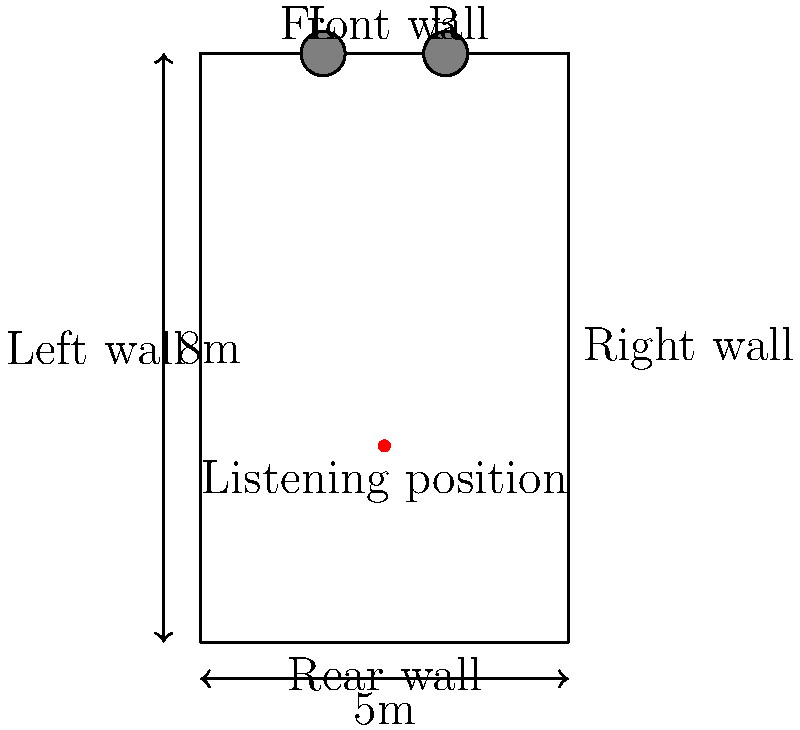In a rectangular room measuring 5m x 8m, where should the speakers be placed for optimal stereo imaging, and what is the ideal distance between them? Assume the listening position is 1/3 of the room length from the rear wall. To determine the optimal speaker placement for stereo imaging in this rectangular room, we'll follow these steps:

1. Identify the listening position:
   - The listening position is 1/3 of the room length from the rear wall.
   - In this case, it's at $8m \times \frac{1}{3} = 2.67m$ from the rear wall.

2. Determine speaker placement:
   - For optimal stereo imaging, speakers should form an equilateral triangle with the listening position.
   - Place speakers along the front wall (8m side).

3. Calculate speaker distance:
   - The distance between speakers should be equal to the distance from each speaker to the listening position.
   - This creates an equilateral triangle.

4. Use the 60-degree rule:
   - In an equilateral triangle, each angle is 60 degrees.
   - The speakers should be placed so that they form a 60-degree angle from the listening position.

5. Calculate the ideal distance:
   - The distance from the listening position to the front wall is $8m - 2.67m = 5.33m$.
   - Using trigonometry, we can calculate the ideal distance between speakers:
     $\text{Speaker Distance} = 2 \times 5.33m \times \tan(30°) \approx 3.08m$

6. Final placement:
   - Place speakers along the front wall, centered in the room.
   - Each speaker should be $\frac{5m - 3.08m}{2} = 0.96m$ from the side walls.

Therefore, the speakers should be placed 3.08m apart along the front wall, with each speaker approximately 0.96m from the nearest side wall.
Answer: 3.08m apart on the front wall, each 0.96m from side walls 